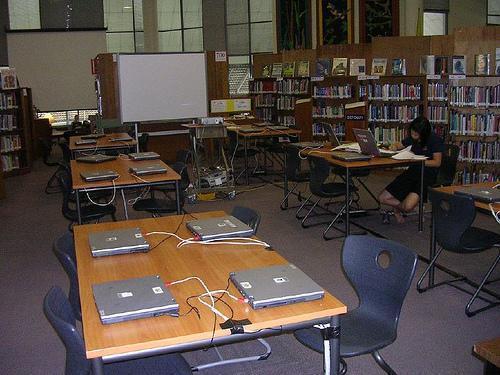Who owns those laptops?
Choose the correct response and explain in the format: 'Answer: answer
Rationale: rationale.'
Options: One individual, library, multiple individuals, non profit. Answer: library.
Rationale: The library owns them. 